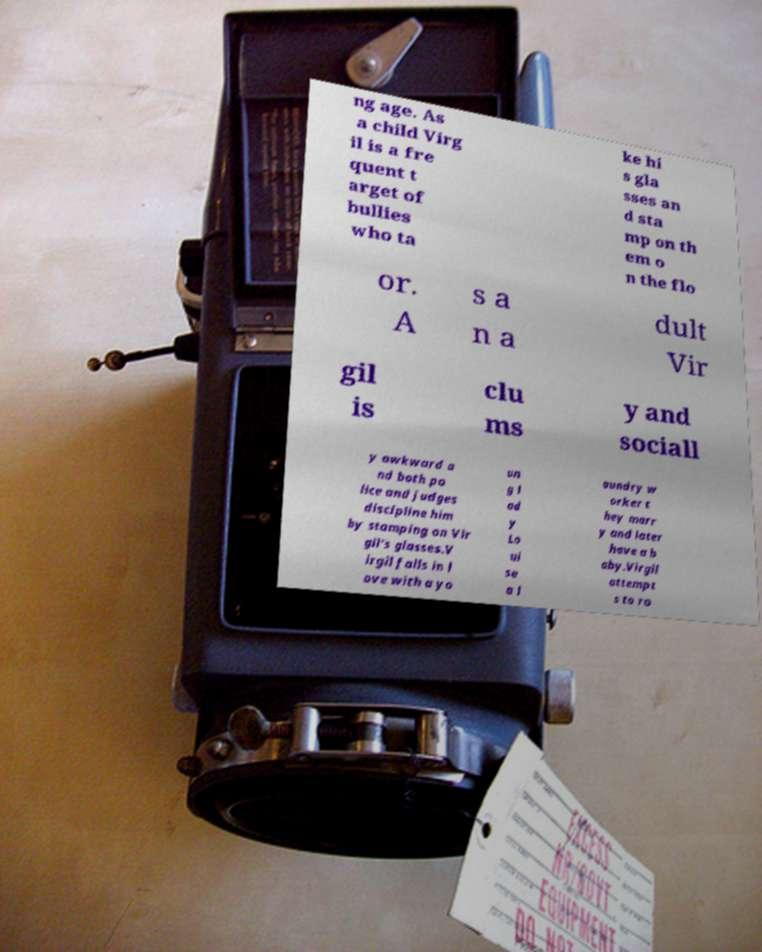Could you extract and type out the text from this image? ng age. As a child Virg il is a fre quent t arget of bullies who ta ke hi s gla sses an d sta mp on th em o n the flo or. A s a n a dult Vir gil is clu ms y and sociall y awkward a nd both po lice and judges discipline him by stamping on Vir gil's glasses.V irgil falls in l ove with a yo un g l ad y Lo ui se a l aundry w orker t hey marr y and later have a b aby.Virgil attempt s to ro 